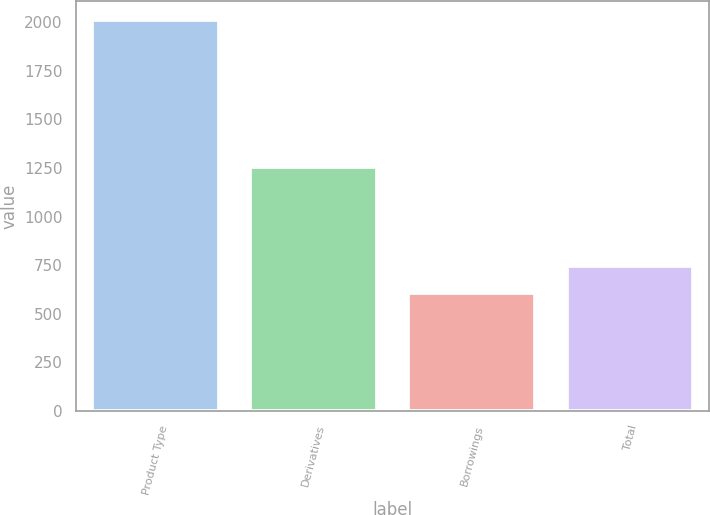<chart> <loc_0><loc_0><loc_500><loc_500><bar_chart><fcel>Product Type<fcel>Derivatives<fcel>Borrowings<fcel>Total<nl><fcel>2010<fcel>1257<fcel>604<fcel>744.6<nl></chart> 